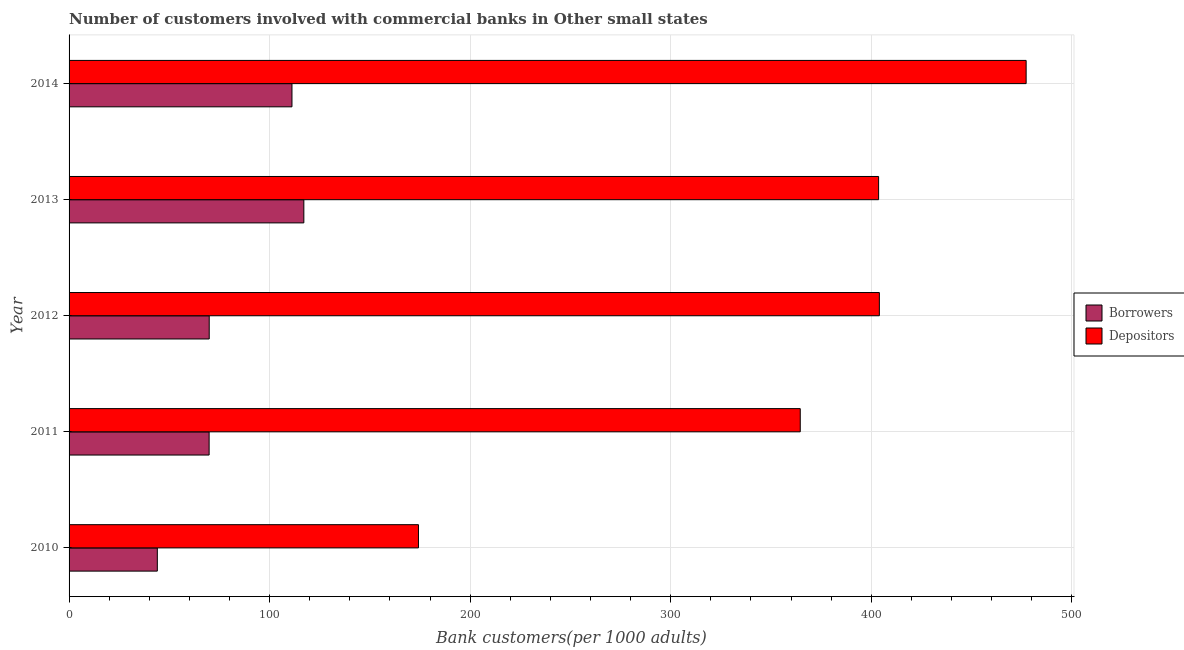How many groups of bars are there?
Make the answer very short. 5. What is the label of the 4th group of bars from the top?
Offer a very short reply. 2011. In how many cases, is the number of bars for a given year not equal to the number of legend labels?
Make the answer very short. 0. What is the number of depositors in 2012?
Make the answer very short. 404.02. Across all years, what is the maximum number of depositors?
Ensure brevity in your answer.  477.2. Across all years, what is the minimum number of depositors?
Keep it short and to the point. 174.21. In which year was the number of borrowers maximum?
Ensure brevity in your answer.  2013. What is the total number of borrowers in the graph?
Make the answer very short. 411.92. What is the difference between the number of borrowers in 2010 and that in 2011?
Ensure brevity in your answer.  -25.83. What is the difference between the number of borrowers in 2011 and the number of depositors in 2014?
Your answer should be very brief. -407.37. What is the average number of depositors per year?
Keep it short and to the point. 364.73. In the year 2012, what is the difference between the number of borrowers and number of depositors?
Ensure brevity in your answer.  -334.13. In how many years, is the number of borrowers greater than 160 ?
Offer a very short reply. 0. What is the ratio of the number of depositors in 2011 to that in 2012?
Your answer should be compact. 0.9. What is the difference between the highest and the second highest number of depositors?
Your answer should be very brief. 73.18. What is the difference between the highest and the lowest number of borrowers?
Ensure brevity in your answer.  73.06. Is the sum of the number of depositors in 2012 and 2013 greater than the maximum number of borrowers across all years?
Your response must be concise. Yes. What does the 2nd bar from the top in 2014 represents?
Keep it short and to the point. Borrowers. What does the 2nd bar from the bottom in 2014 represents?
Provide a short and direct response. Depositors. How many bars are there?
Your answer should be very brief. 10. How many years are there in the graph?
Offer a very short reply. 5. What is the difference between two consecutive major ticks on the X-axis?
Give a very brief answer. 100. Are the values on the major ticks of X-axis written in scientific E-notation?
Your response must be concise. No. What is the title of the graph?
Offer a terse response. Number of customers involved with commercial banks in Other small states. What is the label or title of the X-axis?
Offer a terse response. Bank customers(per 1000 adults). What is the Bank customers(per 1000 adults) of Borrowers in 2010?
Ensure brevity in your answer.  44. What is the Bank customers(per 1000 adults) of Depositors in 2010?
Keep it short and to the point. 174.21. What is the Bank customers(per 1000 adults) in Borrowers in 2011?
Ensure brevity in your answer.  69.83. What is the Bank customers(per 1000 adults) in Depositors in 2011?
Ensure brevity in your answer.  364.57. What is the Bank customers(per 1000 adults) in Borrowers in 2012?
Your response must be concise. 69.88. What is the Bank customers(per 1000 adults) in Depositors in 2012?
Make the answer very short. 404.02. What is the Bank customers(per 1000 adults) in Borrowers in 2013?
Ensure brevity in your answer.  117.06. What is the Bank customers(per 1000 adults) in Depositors in 2013?
Offer a terse response. 403.64. What is the Bank customers(per 1000 adults) in Borrowers in 2014?
Provide a succinct answer. 111.14. What is the Bank customers(per 1000 adults) in Depositors in 2014?
Give a very brief answer. 477.2. Across all years, what is the maximum Bank customers(per 1000 adults) in Borrowers?
Keep it short and to the point. 117.06. Across all years, what is the maximum Bank customers(per 1000 adults) of Depositors?
Offer a very short reply. 477.2. Across all years, what is the minimum Bank customers(per 1000 adults) in Borrowers?
Provide a succinct answer. 44. Across all years, what is the minimum Bank customers(per 1000 adults) in Depositors?
Your answer should be compact. 174.21. What is the total Bank customers(per 1000 adults) in Borrowers in the graph?
Make the answer very short. 411.92. What is the total Bank customers(per 1000 adults) of Depositors in the graph?
Keep it short and to the point. 1823.64. What is the difference between the Bank customers(per 1000 adults) of Borrowers in 2010 and that in 2011?
Offer a terse response. -25.83. What is the difference between the Bank customers(per 1000 adults) in Depositors in 2010 and that in 2011?
Provide a short and direct response. -190.35. What is the difference between the Bank customers(per 1000 adults) in Borrowers in 2010 and that in 2012?
Your response must be concise. -25.88. What is the difference between the Bank customers(per 1000 adults) in Depositors in 2010 and that in 2012?
Provide a succinct answer. -229.8. What is the difference between the Bank customers(per 1000 adults) in Borrowers in 2010 and that in 2013?
Give a very brief answer. -73.06. What is the difference between the Bank customers(per 1000 adults) of Depositors in 2010 and that in 2013?
Ensure brevity in your answer.  -229.42. What is the difference between the Bank customers(per 1000 adults) of Borrowers in 2010 and that in 2014?
Provide a short and direct response. -67.14. What is the difference between the Bank customers(per 1000 adults) in Depositors in 2010 and that in 2014?
Your response must be concise. -302.99. What is the difference between the Bank customers(per 1000 adults) of Borrowers in 2011 and that in 2012?
Make the answer very short. -0.05. What is the difference between the Bank customers(per 1000 adults) in Depositors in 2011 and that in 2012?
Offer a terse response. -39.45. What is the difference between the Bank customers(per 1000 adults) of Borrowers in 2011 and that in 2013?
Offer a terse response. -47.23. What is the difference between the Bank customers(per 1000 adults) in Depositors in 2011 and that in 2013?
Offer a terse response. -39.07. What is the difference between the Bank customers(per 1000 adults) in Borrowers in 2011 and that in 2014?
Your answer should be very brief. -41.31. What is the difference between the Bank customers(per 1000 adults) in Depositors in 2011 and that in 2014?
Keep it short and to the point. -112.63. What is the difference between the Bank customers(per 1000 adults) in Borrowers in 2012 and that in 2013?
Make the answer very short. -47.18. What is the difference between the Bank customers(per 1000 adults) in Depositors in 2012 and that in 2013?
Offer a terse response. 0.38. What is the difference between the Bank customers(per 1000 adults) of Borrowers in 2012 and that in 2014?
Ensure brevity in your answer.  -41.26. What is the difference between the Bank customers(per 1000 adults) of Depositors in 2012 and that in 2014?
Offer a very short reply. -73.18. What is the difference between the Bank customers(per 1000 adults) in Borrowers in 2013 and that in 2014?
Offer a terse response. 5.92. What is the difference between the Bank customers(per 1000 adults) in Depositors in 2013 and that in 2014?
Offer a terse response. -73.56. What is the difference between the Bank customers(per 1000 adults) of Borrowers in 2010 and the Bank customers(per 1000 adults) of Depositors in 2011?
Your answer should be very brief. -320.56. What is the difference between the Bank customers(per 1000 adults) in Borrowers in 2010 and the Bank customers(per 1000 adults) in Depositors in 2012?
Provide a short and direct response. -360.01. What is the difference between the Bank customers(per 1000 adults) in Borrowers in 2010 and the Bank customers(per 1000 adults) in Depositors in 2013?
Offer a very short reply. -359.63. What is the difference between the Bank customers(per 1000 adults) in Borrowers in 2010 and the Bank customers(per 1000 adults) in Depositors in 2014?
Keep it short and to the point. -433.2. What is the difference between the Bank customers(per 1000 adults) in Borrowers in 2011 and the Bank customers(per 1000 adults) in Depositors in 2012?
Give a very brief answer. -334.18. What is the difference between the Bank customers(per 1000 adults) of Borrowers in 2011 and the Bank customers(per 1000 adults) of Depositors in 2013?
Offer a terse response. -333.8. What is the difference between the Bank customers(per 1000 adults) of Borrowers in 2011 and the Bank customers(per 1000 adults) of Depositors in 2014?
Offer a terse response. -407.37. What is the difference between the Bank customers(per 1000 adults) in Borrowers in 2012 and the Bank customers(per 1000 adults) in Depositors in 2013?
Offer a terse response. -333.76. What is the difference between the Bank customers(per 1000 adults) in Borrowers in 2012 and the Bank customers(per 1000 adults) in Depositors in 2014?
Ensure brevity in your answer.  -407.32. What is the difference between the Bank customers(per 1000 adults) in Borrowers in 2013 and the Bank customers(per 1000 adults) in Depositors in 2014?
Offer a very short reply. -360.14. What is the average Bank customers(per 1000 adults) of Borrowers per year?
Your answer should be compact. 82.38. What is the average Bank customers(per 1000 adults) in Depositors per year?
Give a very brief answer. 364.73. In the year 2010, what is the difference between the Bank customers(per 1000 adults) in Borrowers and Bank customers(per 1000 adults) in Depositors?
Provide a succinct answer. -130.21. In the year 2011, what is the difference between the Bank customers(per 1000 adults) in Borrowers and Bank customers(per 1000 adults) in Depositors?
Your response must be concise. -294.73. In the year 2012, what is the difference between the Bank customers(per 1000 adults) of Borrowers and Bank customers(per 1000 adults) of Depositors?
Provide a short and direct response. -334.14. In the year 2013, what is the difference between the Bank customers(per 1000 adults) of Borrowers and Bank customers(per 1000 adults) of Depositors?
Provide a short and direct response. -286.58. In the year 2014, what is the difference between the Bank customers(per 1000 adults) in Borrowers and Bank customers(per 1000 adults) in Depositors?
Offer a very short reply. -366.06. What is the ratio of the Bank customers(per 1000 adults) in Borrowers in 2010 to that in 2011?
Your response must be concise. 0.63. What is the ratio of the Bank customers(per 1000 adults) in Depositors in 2010 to that in 2011?
Ensure brevity in your answer.  0.48. What is the ratio of the Bank customers(per 1000 adults) in Borrowers in 2010 to that in 2012?
Make the answer very short. 0.63. What is the ratio of the Bank customers(per 1000 adults) of Depositors in 2010 to that in 2012?
Your answer should be compact. 0.43. What is the ratio of the Bank customers(per 1000 adults) of Borrowers in 2010 to that in 2013?
Provide a short and direct response. 0.38. What is the ratio of the Bank customers(per 1000 adults) of Depositors in 2010 to that in 2013?
Offer a terse response. 0.43. What is the ratio of the Bank customers(per 1000 adults) of Borrowers in 2010 to that in 2014?
Provide a succinct answer. 0.4. What is the ratio of the Bank customers(per 1000 adults) of Depositors in 2010 to that in 2014?
Provide a short and direct response. 0.37. What is the ratio of the Bank customers(per 1000 adults) of Depositors in 2011 to that in 2012?
Provide a short and direct response. 0.9. What is the ratio of the Bank customers(per 1000 adults) in Borrowers in 2011 to that in 2013?
Give a very brief answer. 0.6. What is the ratio of the Bank customers(per 1000 adults) in Depositors in 2011 to that in 2013?
Provide a short and direct response. 0.9. What is the ratio of the Bank customers(per 1000 adults) of Borrowers in 2011 to that in 2014?
Provide a succinct answer. 0.63. What is the ratio of the Bank customers(per 1000 adults) in Depositors in 2011 to that in 2014?
Your response must be concise. 0.76. What is the ratio of the Bank customers(per 1000 adults) in Borrowers in 2012 to that in 2013?
Provide a short and direct response. 0.6. What is the ratio of the Bank customers(per 1000 adults) in Borrowers in 2012 to that in 2014?
Provide a short and direct response. 0.63. What is the ratio of the Bank customers(per 1000 adults) in Depositors in 2012 to that in 2014?
Ensure brevity in your answer.  0.85. What is the ratio of the Bank customers(per 1000 adults) in Borrowers in 2013 to that in 2014?
Give a very brief answer. 1.05. What is the ratio of the Bank customers(per 1000 adults) of Depositors in 2013 to that in 2014?
Keep it short and to the point. 0.85. What is the difference between the highest and the second highest Bank customers(per 1000 adults) in Borrowers?
Provide a succinct answer. 5.92. What is the difference between the highest and the second highest Bank customers(per 1000 adults) in Depositors?
Provide a succinct answer. 73.18. What is the difference between the highest and the lowest Bank customers(per 1000 adults) of Borrowers?
Provide a short and direct response. 73.06. What is the difference between the highest and the lowest Bank customers(per 1000 adults) of Depositors?
Provide a succinct answer. 302.99. 